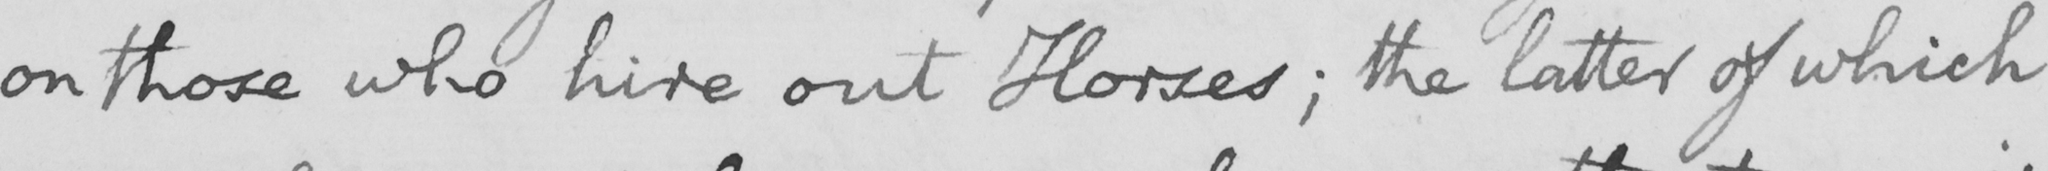Please transcribe the handwritten text in this image. on those who hire out Horses ; the latter of which 